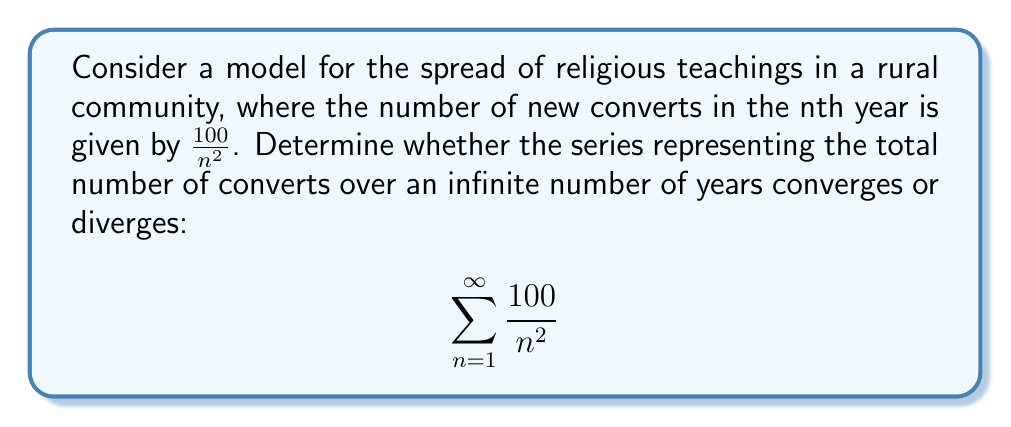Show me your answer to this math problem. To analyze the convergence of this series, we can use the p-series test:

1) The general form of a p-series is $\sum_{n=1}^{\infty} \frac{1}{n^p}$

2) Our series can be rewritten as:
   $$\sum_{n=1}^{\infty} \frac{100}{n^2} = 100 \sum_{n=1}^{\infty} \frac{1}{n^2}$$

3) In this case, $p = 2$

4) For a p-series:
   - If $p > 1$, the series converges
   - If $p \leq 1$, the series diverges

5) Since $p = 2 > 1$, our series converges

6) In fact, this is a scalar multiple of the well-known Basel problem:
   $$\sum_{n=1}^{\infty} \frac{1}{n^2} = \frac{\pi^2}{6}$$

7) Therefore, our series converges to:
   $$100 \cdot \frac{\pi^2}{6} = \frac{50\pi^2}{3}$$

This means that over an infinite number of years, the total number of converts in this model would approach but never exceed $\frac{50\pi^2}{3}$ (approximately 164.49) people.
Answer: Converges to $\frac{50\pi^2}{3}$ 